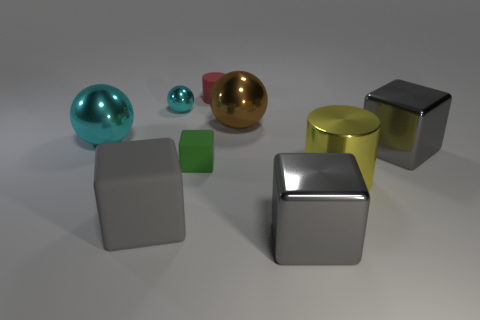How many tiny cyan metal balls are there?
Your answer should be compact. 1. There is a small green object; is it the same shape as the matte thing in front of the large metallic cylinder?
Offer a terse response. Yes. Is the number of big matte blocks that are behind the large cyan object less than the number of large gray metallic objects on the left side of the small cyan metallic sphere?
Provide a succinct answer. No. Are there any other things that are the same shape as the small green matte object?
Give a very brief answer. Yes. Is the shape of the small green rubber thing the same as the large brown thing?
Offer a very short reply. No. Is there any other thing that is made of the same material as the yellow object?
Give a very brief answer. Yes. The gray matte block has what size?
Your answer should be very brief. Large. There is a matte thing that is behind the shiny cylinder and in front of the tiny red rubber cylinder; what is its color?
Ensure brevity in your answer.  Green. Is the number of red objects greater than the number of tiny matte objects?
Provide a short and direct response. No. How many things are yellow metallic cylinders or rubber objects that are behind the big cyan thing?
Your response must be concise. 2. 